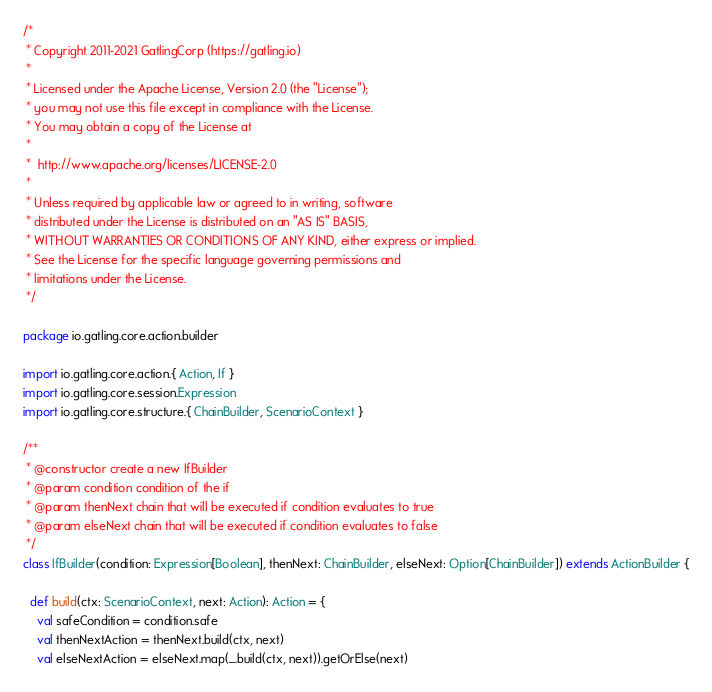<code> <loc_0><loc_0><loc_500><loc_500><_Scala_>/*
 * Copyright 2011-2021 GatlingCorp (https://gatling.io)
 *
 * Licensed under the Apache License, Version 2.0 (the "License");
 * you may not use this file except in compliance with the License.
 * You may obtain a copy of the License at
 *
 *  http://www.apache.org/licenses/LICENSE-2.0
 *
 * Unless required by applicable law or agreed to in writing, software
 * distributed under the License is distributed on an "AS IS" BASIS,
 * WITHOUT WARRANTIES OR CONDITIONS OF ANY KIND, either express or implied.
 * See the License for the specific language governing permissions and
 * limitations under the License.
 */

package io.gatling.core.action.builder

import io.gatling.core.action.{ Action, If }
import io.gatling.core.session.Expression
import io.gatling.core.structure.{ ChainBuilder, ScenarioContext }

/**
 * @constructor create a new IfBuilder
 * @param condition condition of the if
 * @param thenNext chain that will be executed if condition evaluates to true
 * @param elseNext chain that will be executed if condition evaluates to false
 */
class IfBuilder(condition: Expression[Boolean], thenNext: ChainBuilder, elseNext: Option[ChainBuilder]) extends ActionBuilder {

  def build(ctx: ScenarioContext, next: Action): Action = {
    val safeCondition = condition.safe
    val thenNextAction = thenNext.build(ctx, next)
    val elseNextAction = elseNext.map(_.build(ctx, next)).getOrElse(next)</code> 